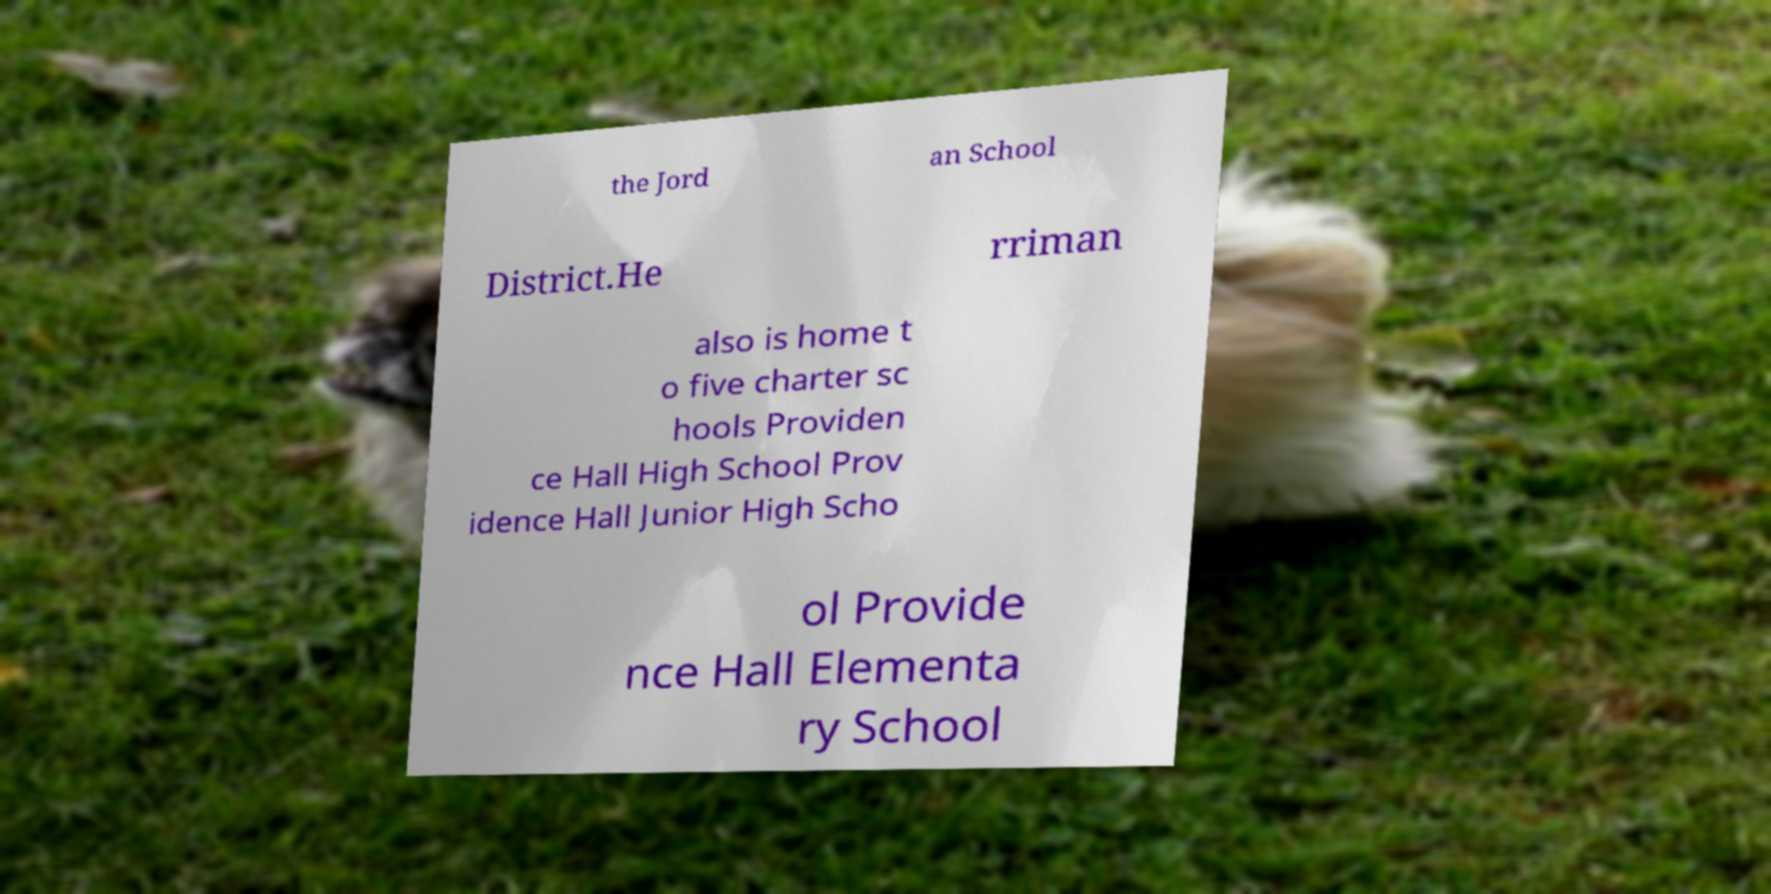Could you assist in decoding the text presented in this image and type it out clearly? the Jord an School District.He rriman also is home t o five charter sc hools Providen ce Hall High School Prov idence Hall Junior High Scho ol Provide nce Hall Elementa ry School 